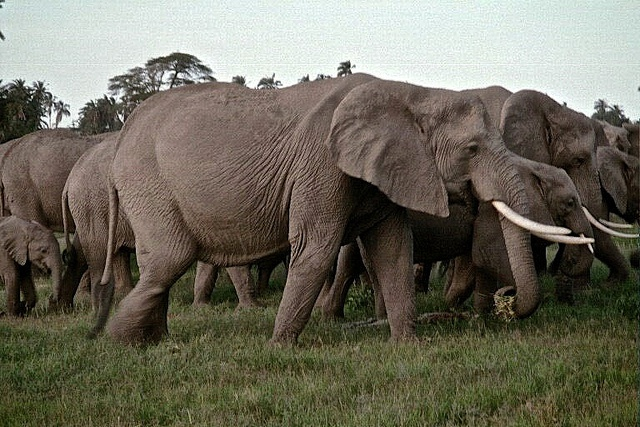Describe the objects in this image and their specific colors. I can see elephant in gray and black tones, elephant in gray and black tones, elephant in gray and black tones, elephant in gray and black tones, and elephant in gray, maroon, and black tones in this image. 